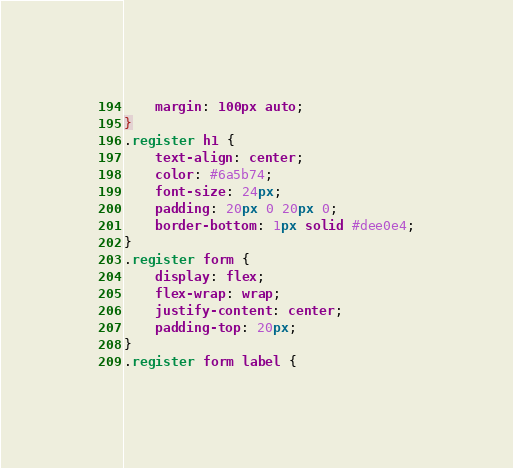Convert code to text. <code><loc_0><loc_0><loc_500><loc_500><_CSS_>  	margin: 100px auto;
}
.register h1 {
  	text-align: center;
  	color: #6a5b74;
  	font-size: 24px;
  	padding: 20px 0 20px 0;
  	border-bottom: 1px solid #dee0e4;
}
.register form {
  	display: flex;
  	flex-wrap: wrap;
  	justify-content: center;
  	padding-top: 20px;
}
.register form label {</code> 